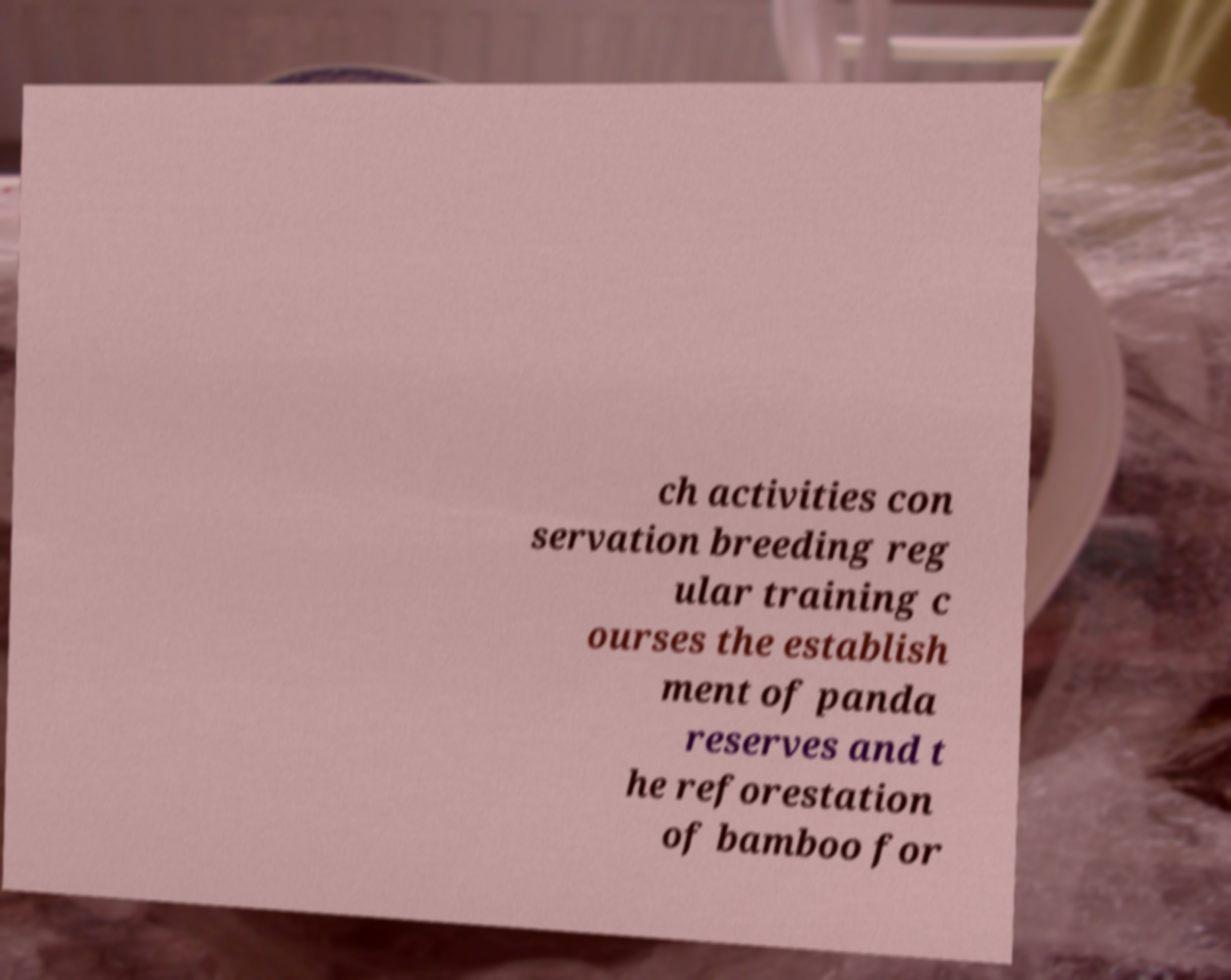Can you accurately transcribe the text from the provided image for me? ch activities con servation breeding reg ular training c ourses the establish ment of panda reserves and t he reforestation of bamboo for 